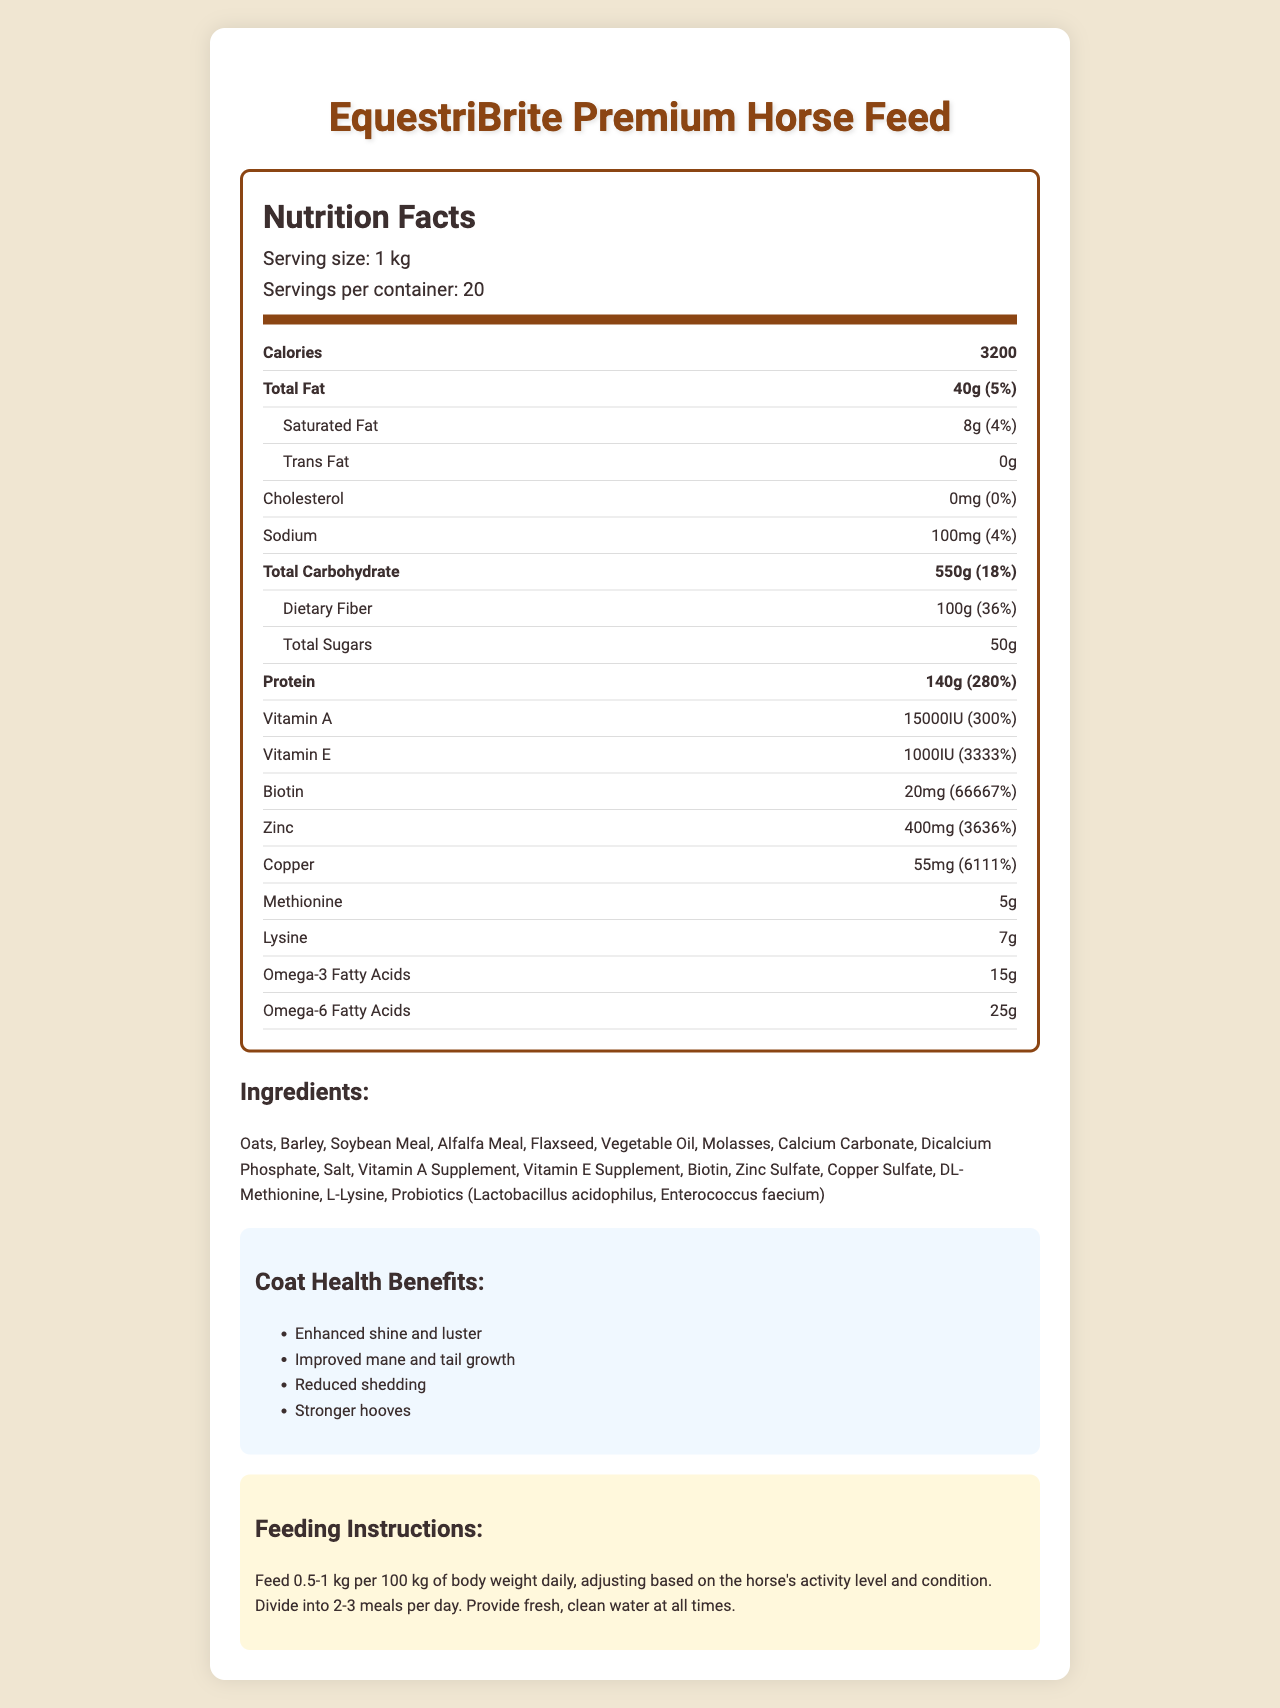what is the product name? The product name is stated at the top of the document under the title "Nutrition Facts."
Answer: EquestriBrite Premium Horse Feed what is the serving size for the feed? The serving size is indicated in the "Nutrition Facts" section as "Serving size: 1 kg."
Answer: 1 kg how many servings are there per container? The number of servings per container is mentioned in the "Nutrition Facts" section as "Servings per container: 20."
Answer: 20 how many calories are in one serving of this horse feed? The calorie count per serving is listed in the "Nutrition Facts" section as "Calories: 3200."
Answer: 3200 what are the instructions for feeding this horse feed? The feeding instructions are provided in a specific section titled "Feeding Instructions."
Answer: Feed 0.5-1 kg per 100 kg of body weight daily, adjusting based on the horse's activity level and condition. Divide into 2-3 meals per day. Provide fresh, clean water at all times. which vitamin has the highest daily value percentage? A. Vitamin A B. Vitamin E C. Biotin D. Zinc The daily value percentage for Biotin is 66667%, which is the highest among the listed vitamins.
Answer: C how much total fat is in one serving of the horse feed? A. 40g B. 50g C. 60g The total fat content is specified as 40g per serving in the "Nutrition Facts" section.
Answer: A does this feed contain any trans fat? The "Nutrition Facts" section lists the trans fat content as "0g."
Answer: No describe the main idea of this document. The document is a detailed nutritional label that offers extensive information about the product, such as nutritional content, ingredients, benefits for coat health, and how to feed it.
Answer: The document provides nutritional information, ingredients, coat health benefits, and feeding instructions for EquestriBrite Premium Horse Feed. what is the daily value percentage of protein in this horse feed? The daily value percentage of protein is given as 280% in the "Nutrition Facts" section.
Answer: 280% how much dietary fiber is in one serving, and what is its daily value percentage? The "Nutrition Facts" section indicates that there are 100g of dietary fiber per serving, and the daily value is 36%.
Answer: 100g, 36% name three ingredients in this horse feed. The ingredients are listed in an "Ingredients" section, and examples include Oats, Barley, and Soybean Meal.
Answer: Oats, Barley, Soybean Meal what are the listed benefits for coat health? The benefits are explicitly listed in the "Coat Health Benefits" section.
Answer: Enhanced shine and luster, Improved mane and tail growth, Reduced shedding, Stronger hooves is the amount of cholesterol in the feed high? The "Nutrition Facts" section lists the cholesterol content as 0mg, which means there is no cholesterol, making it not high at all.
Answer: No what is the sodium content and its daily value percentage? The sodium content is shown as 100mg with a daily value percentage of 4% in the "Nutrition Facts" section.
Answer: 100mg, 4% how many grams of methionine are in one serving? The methionine content is specified as 5g per serving in the "Nutrition Facts" section. The daily value is marked as "N/A."
Answer: 5g what is the biotin content per serving? A. 10mg B. 15mg C. 20mg D. 25mg The "Nutrition Facts" section lists the biotin content as 20mg.
Answer: C is the feed appropriate for horses with a need for high Omega-3 fatty acids? The feed contains 15g of Omega-3 fatty acids per serving, as listed in the "Nutrition Facts" section, which is beneficial.
Answer: Yes list all the probiotic strains included in this feed. The ingredients list includes the probiotic strains Lactobacillus acidophilus and Enterococcus faecium.
Answer: Lactobacillus acidophilus, Enterococcus faecium how can you adjust the feeding amount based on the horse's activity level and condition? The feeding instructions indicate to adjust based on the horse's activity level and condition, within the specified range.
Answer: By adjusting the feed within the range of 0.5-1 kg per 100 kg of body weight daily. what is the daily value percentage of zinc in one serving? The "Nutrition Facts" section provides the daily value percentage for zinc as 3636%.
Answer: 3636% how much copper is in one serving of the feed? A. 50mg B. 55mg C. 60mg D. 65mg The "Nutrition Facts" section lists the copper content as 55mg.
Answer: B is the amount of lysine included in the daily value percentage? The daily value for lysine is marked as "N/A" in the "Nutrition Facts" section, meaning it is not included.
Answer: No how many IU of Vitamin E are in each serving? The "Nutrition Facts" section lists 1000IU of Vitamin E per serving.
Answer: 1000IU is there enough information provided to determine the exact manufacturing process of this feed? The document provides nutritional information, ingredients, and benefits but does not detail the manufacturing process.
Answer: No 